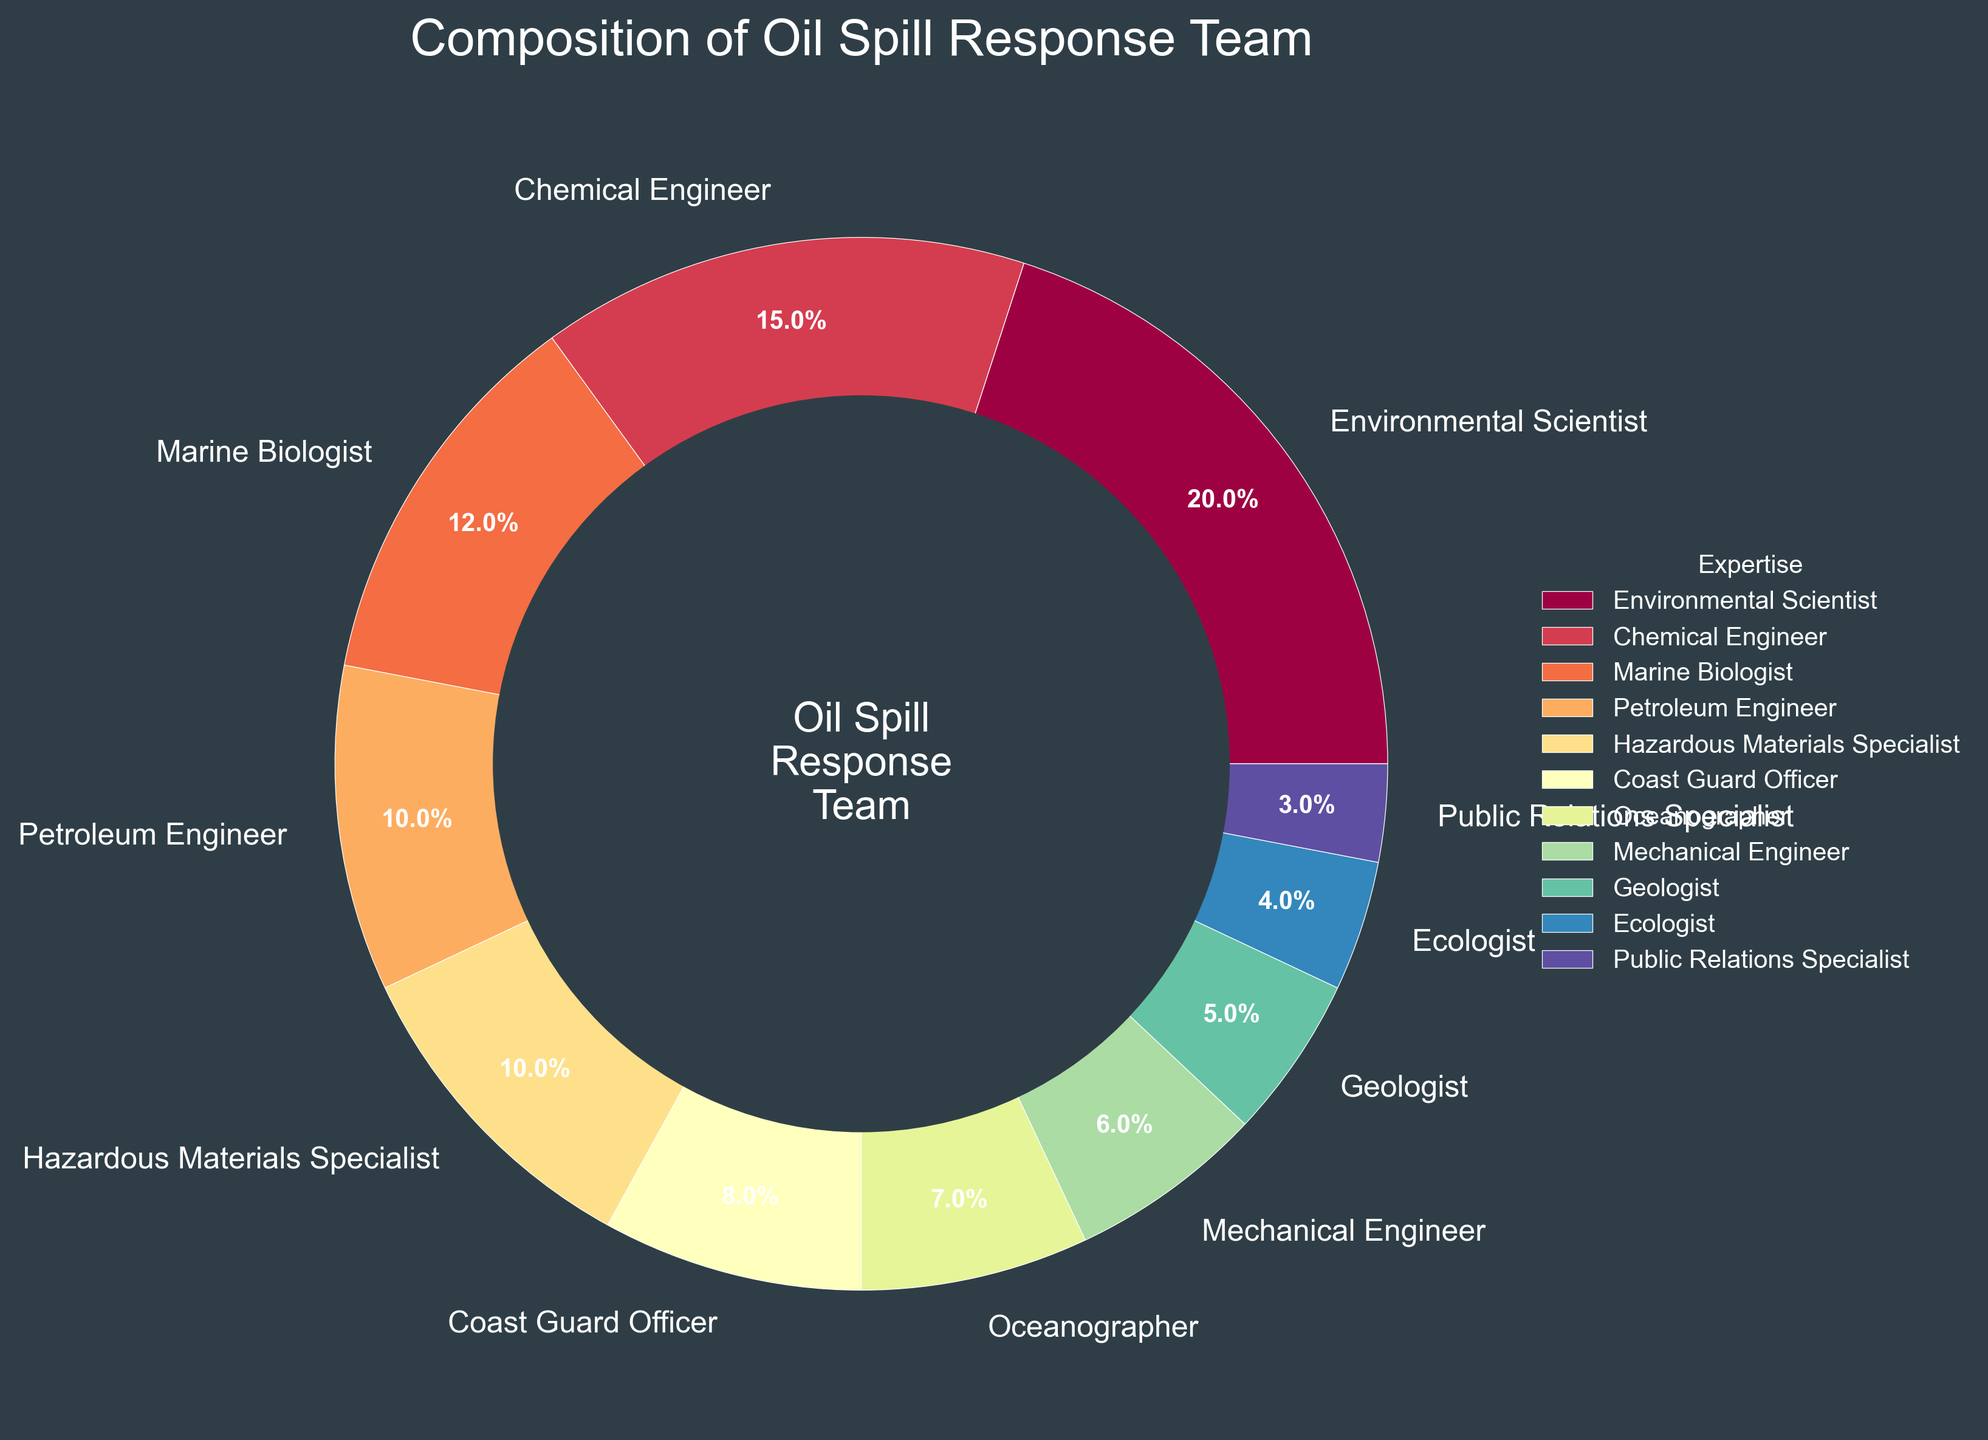What percentage of the oil spill response team is composed of Petroleum Engineer and Chemical Engineer combined? The percentage of Petroleum Engineer is 10%, and the percentage of Chemical Engineer is 15%. Sum these two percentages to get the total combined percentage: 10% + 15% = 25%.
Answer: 25% Which expertise has a greater representation, Marine Biologist or Oceanographer? The percentage of Marine Biologist is 12%, while the percentage of Oceanographer is 7%. Since 12% is greater than 7%, Marine Biologist has a greater representation.
Answer: Marine Biologist What is the least represented expertise in the oil spill response team? The expertise with the smallest percentage is the least represented. Among the given percentages, Public Relations Specialist has the lowest percentage at 3%.
Answer: Public Relations Specialist How does the percentage representation of Environmental Scientist compare with that of Geologist and Ecologist combined? The percentage of Environmental Scientist is 20%. The combined percentage of Geologist (5%) and Ecologist (4%) is 5% + 4% = 9%. Since 20% is greater than 9%, Environmental Scientist has a higher percentage representation.
Answer: Environmental Scientist What's the difference in percentage between the most and the least represented expertise? The most represented expertise is Environmental Scientist at 20%, and the least represented expertise is Public Relations Specialist at 3%. The difference is 20% - 3% = 17%.
Answer: 17% Which three expertises combined make up the largest portion of the team? The three highest percentages are 20% (Environmental Scientist), 15% (Chemical Engineer), and 12% (Marine Biologist). Combining them gives 20% + 15% + 12% = 47%.
Answer: Environmental Scientist, Chemical Engineer, Marine Biologist What is the average percentage representation of Mechanical Engineer, Geologist, and Ecologist? The percentages are Mechanical Engineer (6%), Geologist (5%), and Ecologist (4%). The average is calculated as (6% + 5% + 4%) / 3 = 15% / 3 = 5%.
Answer: 5% How is the visual representation of the largest wedge visually distinguished from the smallest wedge? The largest wedge represents Environmental Scientist with 20%, and it appears noticeably larger visually. The smallest wedge represents Public Relations Specialist with 3%, and it appears much smaller. The largest wedge is similarly colored in the pie slice with distinct separation feel due to its size, while the smallest wedge looks more compact.
Answer: Larger and smaller wedges have noticeable size difference What percentage of the oil spill response team is composed of non-engineer roles (sum of all roles that are not engineers)? The non-engineer roles are Environmental Scientist (20%), Marine Biologist (12%), Hazardous Materials Specialist (10%), Coast Guard Officer (8%), Oceanographer (7%), Geologist (5%), Ecologist (4%), Public Relations Specialist (3%). Sum these percentages: 20% + 12% + 10% + 8% + 7% + 5% + 4% + 3% = 69%.
Answer: 69% How does the visual representation of engineers compare to non-engineers based on color variety in the pie chart? The slices representing engineers use colors from the same colormap (Spectral), but engineer slices are often found clustered close together, giving a more concentrated visual feel compared to the more dispersed non-engineer slices. Engineers’ slices: Chemical (15%), Petroleum (10%), Mechanical (6%) total 31% while non-engineers total 69% and are more dispersed.
Answer: Engineers are more clustered visually and non-engineers are more dispersed 